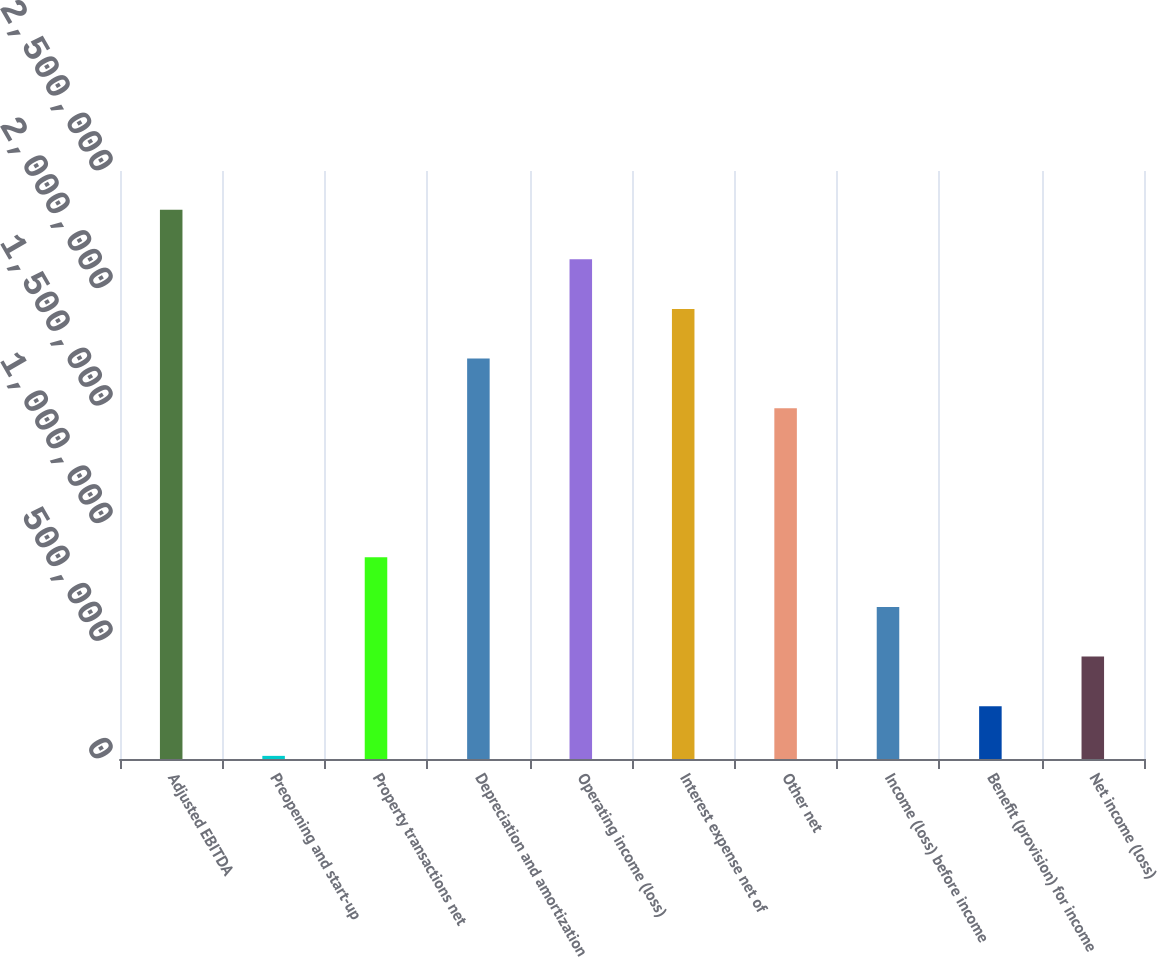Convert chart. <chart><loc_0><loc_0><loc_500><loc_500><bar_chart><fcel>Adjusted EBITDA<fcel>Preopening and start-up<fcel>Property transactions net<fcel>Depreciation and amortization<fcel>Operating income (loss)<fcel>Interest expense net of<fcel>Other net<fcel>Income (loss) before income<fcel>Benefit (provision) for income<fcel>Net income (loss)<nl><fcel>2.33571e+06<fcel>13314<fcel>857821<fcel>1.70233e+06<fcel>2.12458e+06<fcel>1.91345e+06<fcel>1.4912e+06<fcel>646694<fcel>224441<fcel>435567<nl></chart> 